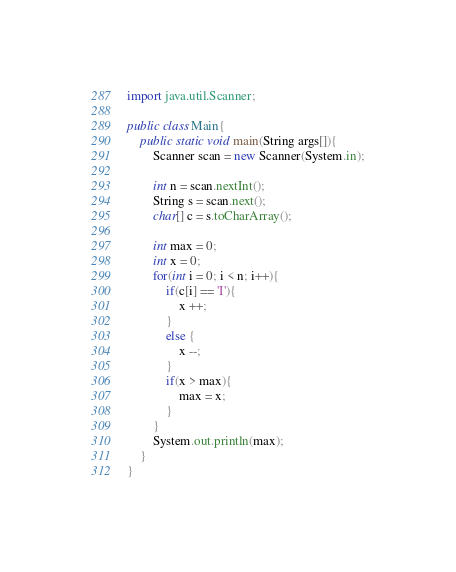Convert code to text. <code><loc_0><loc_0><loc_500><loc_500><_Java_>import java.util.Scanner;

public class Main{
	public static void main(String args[]){
		Scanner scan = new Scanner(System.in);

		int n = scan.nextInt();
		String s = scan.next();
		char[] c = s.toCharArray();

		int max = 0;
		int x = 0;
		for(int i = 0; i < n; i++){
			if(c[i] == 'I'){
				x ++;
			}
			else {
				x --;
			}
			if(x > max){
				max = x;
			}
		}
		System.out.println(max);
	}
}
</code> 